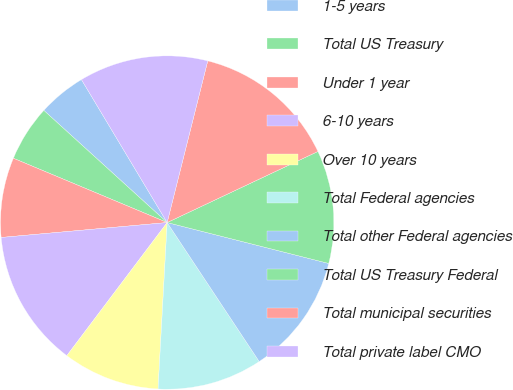Convert chart to OTSL. <chart><loc_0><loc_0><loc_500><loc_500><pie_chart><fcel>1-5 years<fcel>Total US Treasury<fcel>Under 1 year<fcel>6-10 years<fcel>Over 10 years<fcel>Total Federal agencies<fcel>Total other Federal agencies<fcel>Total US Treasury Federal<fcel>Total municipal securities<fcel>Total private label CMO<nl><fcel>4.66%<fcel>5.44%<fcel>7.73%<fcel>13.29%<fcel>9.41%<fcel>10.18%<fcel>11.74%<fcel>10.96%<fcel>14.07%<fcel>12.51%<nl></chart> 